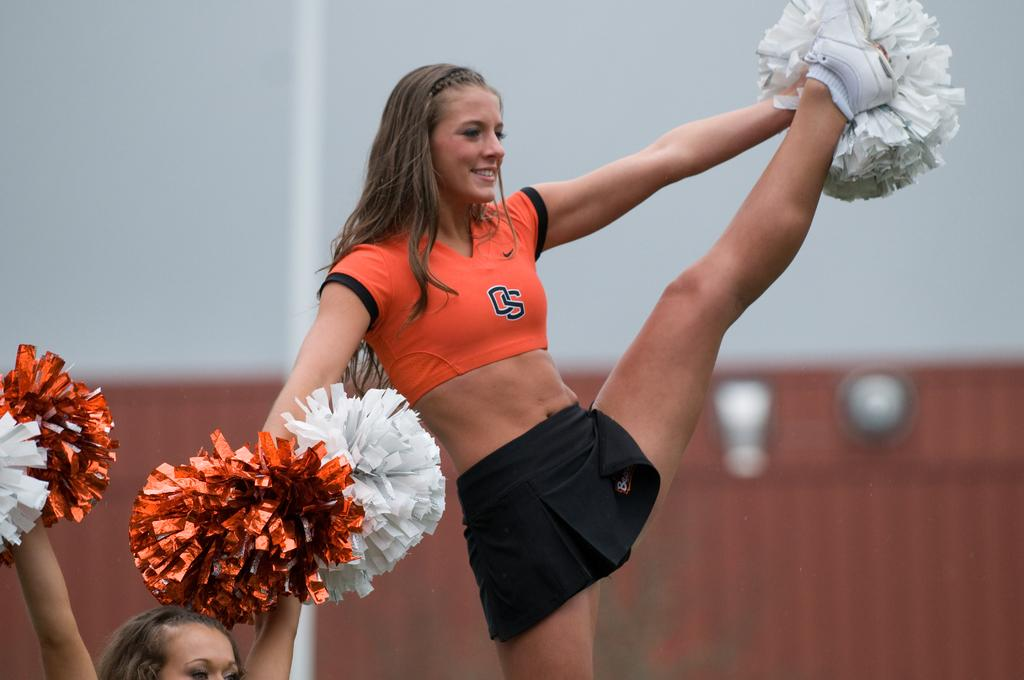<image>
Create a compact narrative representing the image presented. the cheer leader has letter O and S on her top 